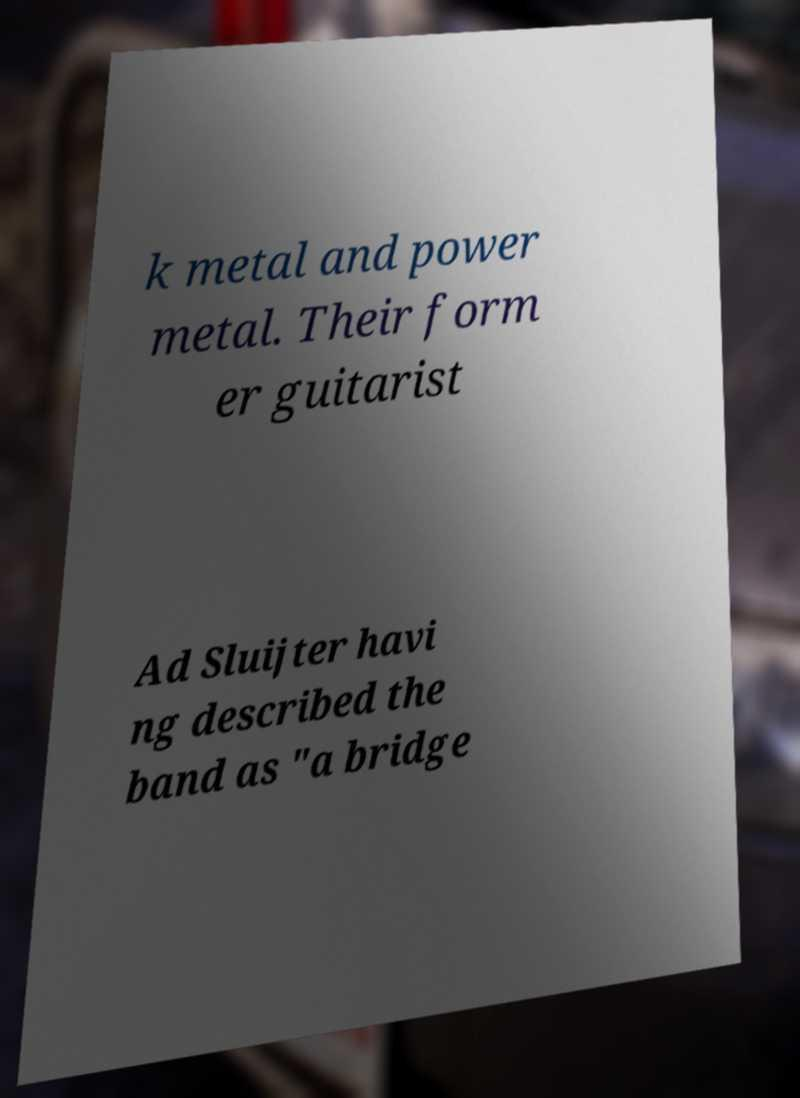Please identify and transcribe the text found in this image. k metal and power metal. Their form er guitarist Ad Sluijter havi ng described the band as "a bridge 